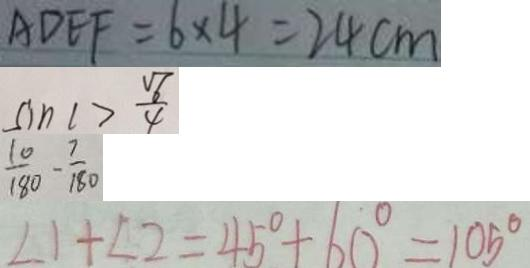Convert formula to latex. <formula><loc_0><loc_0><loc_500><loc_500>A D E F = 6 \times 4 = 2 4 c m 
 \sin C > \frac { \sqrt { 6 } } { 4 } 
 \frac { 1 0 } { 1 8 0 } - \frac { 7 } { 1 8 0 } 
 \angle 1 + \angle 2 = 4 5 ^ { \circ } + 6 0 ^ { \circ } = 1 0 5 ^ { \circ }</formula> 